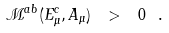Convert formula to latex. <formula><loc_0><loc_0><loc_500><loc_500>\mathcal { M } ^ { a b } ( E _ { \mu } ^ { c } , A _ { \mu } ) \ > \ 0 \ .</formula> 